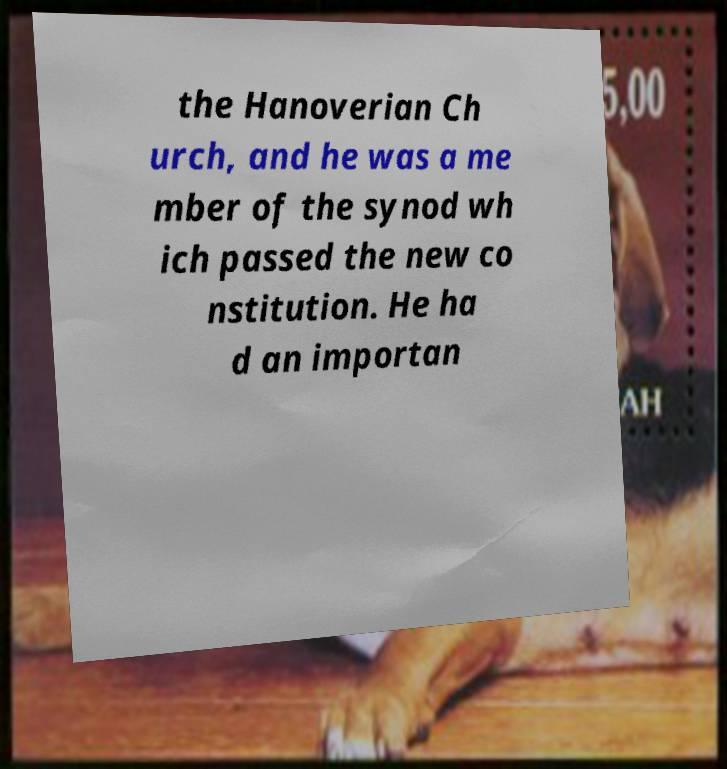What messages or text are displayed in this image? I need them in a readable, typed format. the Hanoverian Ch urch, and he was a me mber of the synod wh ich passed the new co nstitution. He ha d an importan 